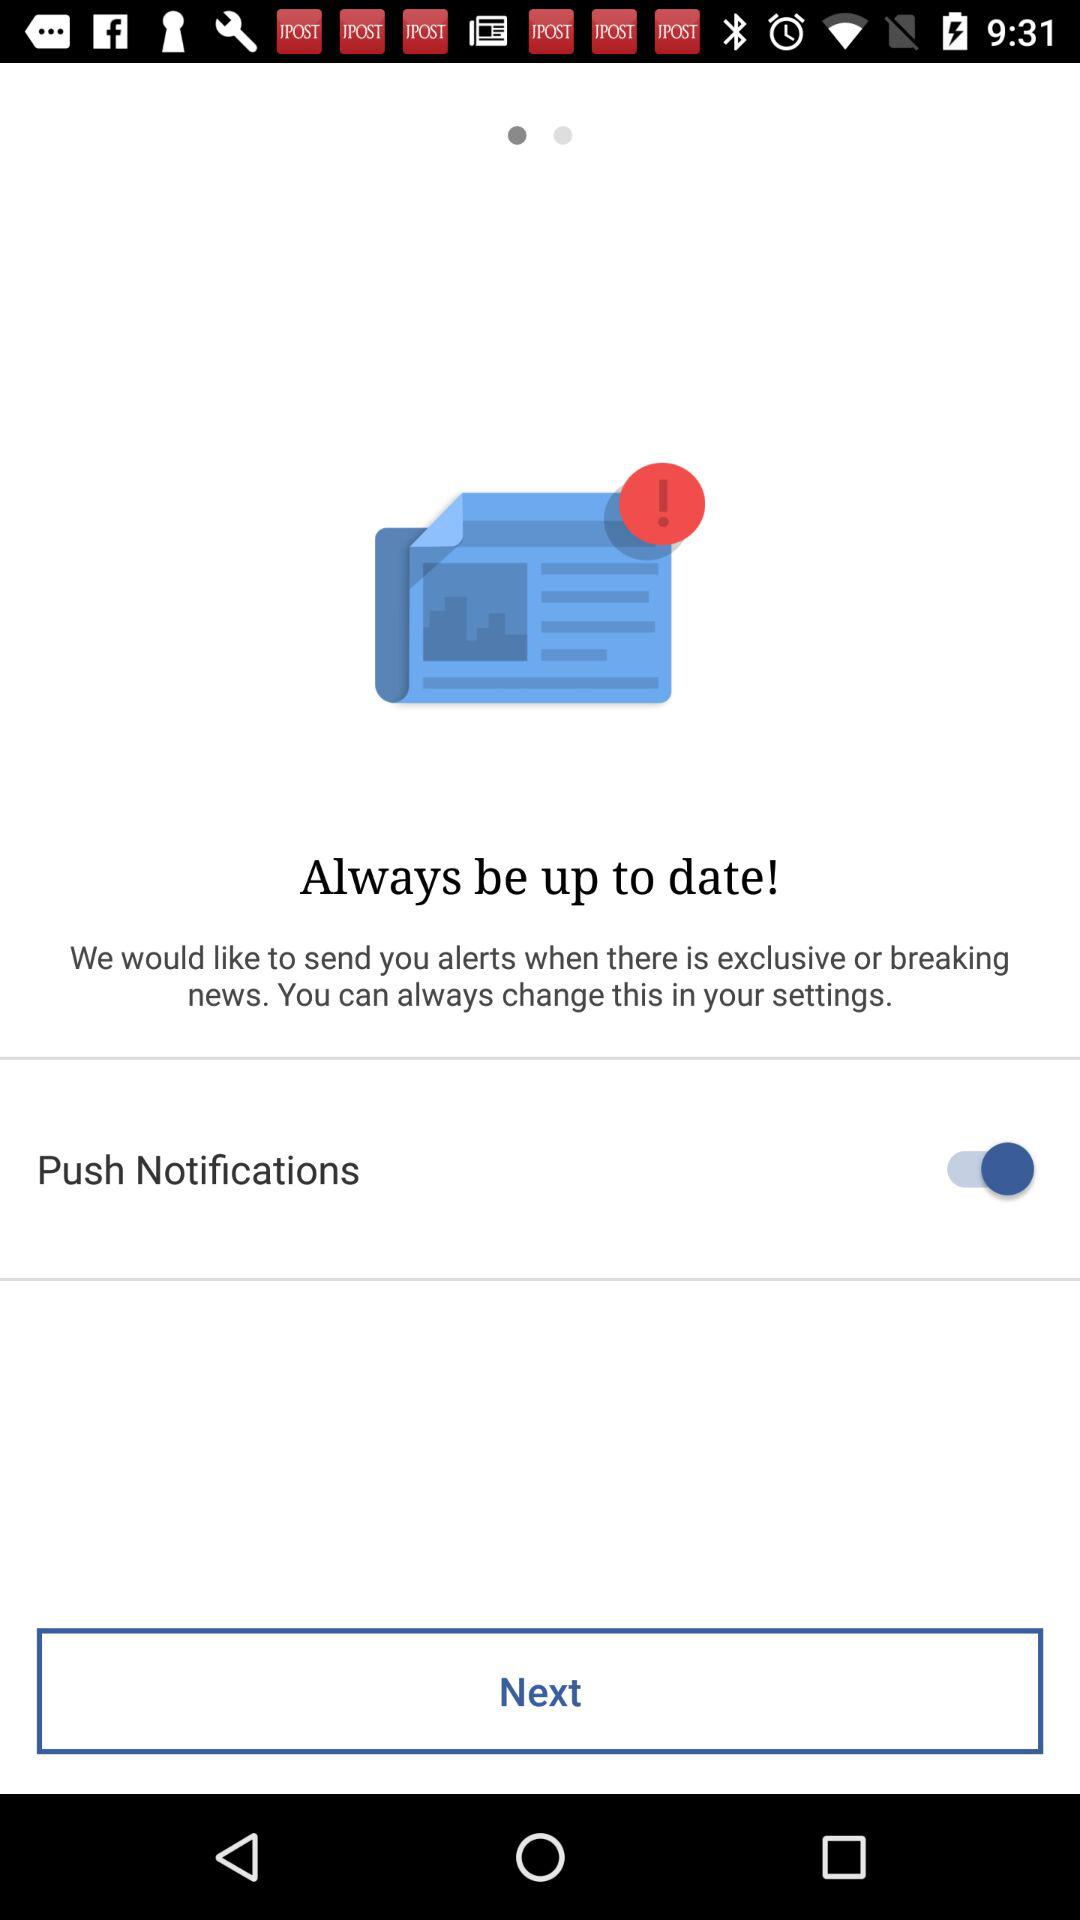What is the status of "Push Notifications"? The status of "Push Notifications" is "on". 